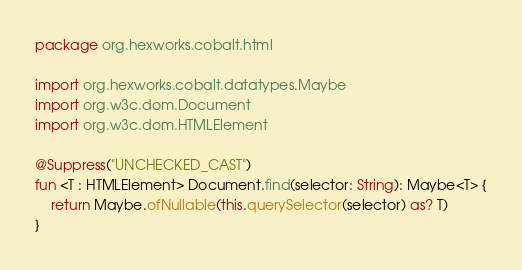Convert code to text. <code><loc_0><loc_0><loc_500><loc_500><_Kotlin_>package org.hexworks.cobalt.html

import org.hexworks.cobalt.datatypes.Maybe
import org.w3c.dom.Document
import org.w3c.dom.HTMLElement

@Suppress("UNCHECKED_CAST")
fun <T : HTMLElement> Document.find(selector: String): Maybe<T> {
    return Maybe.ofNullable(this.querySelector(selector) as? T)
}
</code> 